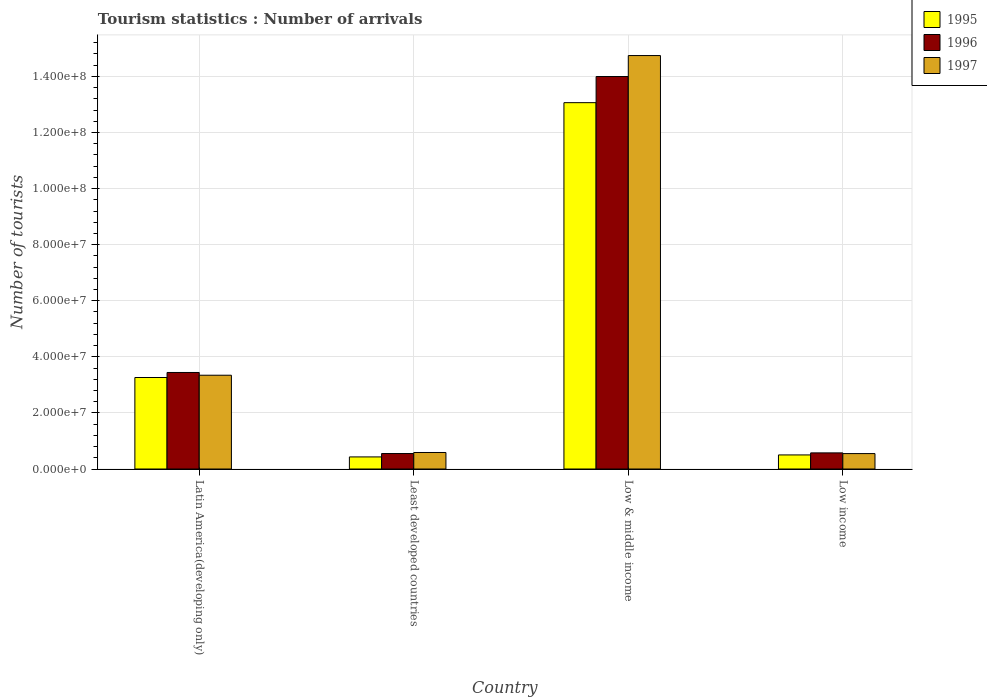Are the number of bars on each tick of the X-axis equal?
Keep it short and to the point. Yes. How many bars are there on the 3rd tick from the left?
Ensure brevity in your answer.  3. What is the label of the 2nd group of bars from the left?
Ensure brevity in your answer.  Least developed countries. What is the number of tourist arrivals in 1995 in Least developed countries?
Keep it short and to the point. 4.31e+06. Across all countries, what is the maximum number of tourist arrivals in 1995?
Provide a succinct answer. 1.31e+08. Across all countries, what is the minimum number of tourist arrivals in 1997?
Provide a succinct answer. 5.50e+06. In which country was the number of tourist arrivals in 1996 maximum?
Provide a short and direct response. Low & middle income. In which country was the number of tourist arrivals in 1996 minimum?
Your response must be concise. Least developed countries. What is the total number of tourist arrivals in 1996 in the graph?
Your answer should be compact. 1.86e+08. What is the difference between the number of tourist arrivals in 1996 in Latin America(developing only) and that in Least developed countries?
Provide a short and direct response. 2.89e+07. What is the difference between the number of tourist arrivals in 1997 in Least developed countries and the number of tourist arrivals in 1995 in Latin America(developing only)?
Offer a very short reply. -2.67e+07. What is the average number of tourist arrivals in 1996 per country?
Your answer should be compact. 4.64e+07. What is the difference between the number of tourist arrivals of/in 1996 and number of tourist arrivals of/in 1997 in Least developed countries?
Your answer should be very brief. -3.73e+05. In how many countries, is the number of tourist arrivals in 1996 greater than 8000000?
Keep it short and to the point. 2. What is the ratio of the number of tourist arrivals in 1997 in Least developed countries to that in Low & middle income?
Offer a very short reply. 0.04. Is the number of tourist arrivals in 1996 in Latin America(developing only) less than that in Least developed countries?
Offer a very short reply. No. What is the difference between the highest and the second highest number of tourist arrivals in 1996?
Your answer should be very brief. -1.06e+08. What is the difference between the highest and the lowest number of tourist arrivals in 1996?
Your response must be concise. 1.34e+08. In how many countries, is the number of tourist arrivals in 1995 greater than the average number of tourist arrivals in 1995 taken over all countries?
Give a very brief answer. 1. What does the 3rd bar from the left in Low & middle income represents?
Ensure brevity in your answer.  1997. What does the 1st bar from the right in Low income represents?
Make the answer very short. 1997. Is it the case that in every country, the sum of the number of tourist arrivals in 1996 and number of tourist arrivals in 1997 is greater than the number of tourist arrivals in 1995?
Ensure brevity in your answer.  Yes. How many countries are there in the graph?
Make the answer very short. 4. What is the difference between two consecutive major ticks on the Y-axis?
Offer a very short reply. 2.00e+07. Are the values on the major ticks of Y-axis written in scientific E-notation?
Provide a short and direct response. Yes. Does the graph contain any zero values?
Your response must be concise. No. Does the graph contain grids?
Your answer should be compact. Yes. What is the title of the graph?
Provide a succinct answer. Tourism statistics : Number of arrivals. What is the label or title of the X-axis?
Your response must be concise. Country. What is the label or title of the Y-axis?
Your answer should be very brief. Number of tourists. What is the Number of tourists in 1995 in Latin America(developing only)?
Ensure brevity in your answer.  3.26e+07. What is the Number of tourists in 1996 in Latin America(developing only)?
Keep it short and to the point. 3.44e+07. What is the Number of tourists of 1997 in Latin America(developing only)?
Your answer should be compact. 3.34e+07. What is the Number of tourists in 1995 in Least developed countries?
Make the answer very short. 4.31e+06. What is the Number of tourists in 1996 in Least developed countries?
Your answer should be compact. 5.52e+06. What is the Number of tourists in 1997 in Least developed countries?
Offer a very short reply. 5.89e+06. What is the Number of tourists in 1995 in Low & middle income?
Provide a succinct answer. 1.31e+08. What is the Number of tourists of 1996 in Low & middle income?
Offer a very short reply. 1.40e+08. What is the Number of tourists in 1997 in Low & middle income?
Offer a terse response. 1.47e+08. What is the Number of tourists in 1995 in Low income?
Your answer should be very brief. 5.03e+06. What is the Number of tourists of 1996 in Low income?
Provide a succinct answer. 5.75e+06. What is the Number of tourists of 1997 in Low income?
Make the answer very short. 5.50e+06. Across all countries, what is the maximum Number of tourists in 1995?
Keep it short and to the point. 1.31e+08. Across all countries, what is the maximum Number of tourists in 1996?
Make the answer very short. 1.40e+08. Across all countries, what is the maximum Number of tourists in 1997?
Ensure brevity in your answer.  1.47e+08. Across all countries, what is the minimum Number of tourists of 1995?
Keep it short and to the point. 4.31e+06. Across all countries, what is the minimum Number of tourists of 1996?
Ensure brevity in your answer.  5.52e+06. Across all countries, what is the minimum Number of tourists in 1997?
Provide a succinct answer. 5.50e+06. What is the total Number of tourists in 1995 in the graph?
Give a very brief answer. 1.73e+08. What is the total Number of tourists of 1996 in the graph?
Keep it short and to the point. 1.86e+08. What is the total Number of tourists in 1997 in the graph?
Your answer should be very brief. 1.92e+08. What is the difference between the Number of tourists of 1995 in Latin America(developing only) and that in Least developed countries?
Offer a terse response. 2.83e+07. What is the difference between the Number of tourists in 1996 in Latin America(developing only) and that in Least developed countries?
Keep it short and to the point. 2.89e+07. What is the difference between the Number of tourists of 1997 in Latin America(developing only) and that in Least developed countries?
Provide a succinct answer. 2.76e+07. What is the difference between the Number of tourists of 1995 in Latin America(developing only) and that in Low & middle income?
Your answer should be very brief. -9.80e+07. What is the difference between the Number of tourists in 1996 in Latin America(developing only) and that in Low & middle income?
Your answer should be compact. -1.06e+08. What is the difference between the Number of tourists of 1997 in Latin America(developing only) and that in Low & middle income?
Offer a terse response. -1.14e+08. What is the difference between the Number of tourists of 1995 in Latin America(developing only) and that in Low income?
Provide a short and direct response. 2.76e+07. What is the difference between the Number of tourists of 1996 in Latin America(developing only) and that in Low income?
Your answer should be compact. 2.87e+07. What is the difference between the Number of tourists in 1997 in Latin America(developing only) and that in Low income?
Make the answer very short. 2.79e+07. What is the difference between the Number of tourists in 1995 in Least developed countries and that in Low & middle income?
Your response must be concise. -1.26e+08. What is the difference between the Number of tourists in 1996 in Least developed countries and that in Low & middle income?
Provide a short and direct response. -1.34e+08. What is the difference between the Number of tourists in 1997 in Least developed countries and that in Low & middle income?
Your response must be concise. -1.42e+08. What is the difference between the Number of tourists in 1995 in Least developed countries and that in Low income?
Keep it short and to the point. -7.12e+05. What is the difference between the Number of tourists in 1996 in Least developed countries and that in Low income?
Keep it short and to the point. -2.32e+05. What is the difference between the Number of tourists in 1997 in Least developed countries and that in Low income?
Provide a succinct answer. 3.90e+05. What is the difference between the Number of tourists of 1995 in Low & middle income and that in Low income?
Make the answer very short. 1.26e+08. What is the difference between the Number of tourists in 1996 in Low & middle income and that in Low income?
Your answer should be very brief. 1.34e+08. What is the difference between the Number of tourists in 1997 in Low & middle income and that in Low income?
Give a very brief answer. 1.42e+08. What is the difference between the Number of tourists of 1995 in Latin America(developing only) and the Number of tourists of 1996 in Least developed countries?
Your answer should be compact. 2.71e+07. What is the difference between the Number of tourists of 1995 in Latin America(developing only) and the Number of tourists of 1997 in Least developed countries?
Ensure brevity in your answer.  2.67e+07. What is the difference between the Number of tourists of 1996 in Latin America(developing only) and the Number of tourists of 1997 in Least developed countries?
Your answer should be very brief. 2.85e+07. What is the difference between the Number of tourists in 1995 in Latin America(developing only) and the Number of tourists in 1996 in Low & middle income?
Keep it short and to the point. -1.07e+08. What is the difference between the Number of tourists of 1995 in Latin America(developing only) and the Number of tourists of 1997 in Low & middle income?
Offer a very short reply. -1.15e+08. What is the difference between the Number of tourists in 1996 in Latin America(developing only) and the Number of tourists in 1997 in Low & middle income?
Offer a terse response. -1.13e+08. What is the difference between the Number of tourists in 1995 in Latin America(developing only) and the Number of tourists in 1996 in Low income?
Your answer should be very brief. 2.69e+07. What is the difference between the Number of tourists in 1995 in Latin America(developing only) and the Number of tourists in 1997 in Low income?
Give a very brief answer. 2.71e+07. What is the difference between the Number of tourists in 1996 in Latin America(developing only) and the Number of tourists in 1997 in Low income?
Your response must be concise. 2.89e+07. What is the difference between the Number of tourists of 1995 in Least developed countries and the Number of tourists of 1996 in Low & middle income?
Ensure brevity in your answer.  -1.36e+08. What is the difference between the Number of tourists of 1995 in Least developed countries and the Number of tourists of 1997 in Low & middle income?
Give a very brief answer. -1.43e+08. What is the difference between the Number of tourists of 1996 in Least developed countries and the Number of tourists of 1997 in Low & middle income?
Your answer should be compact. -1.42e+08. What is the difference between the Number of tourists of 1995 in Least developed countries and the Number of tourists of 1996 in Low income?
Your response must be concise. -1.44e+06. What is the difference between the Number of tourists in 1995 in Least developed countries and the Number of tourists in 1997 in Low income?
Make the answer very short. -1.19e+06. What is the difference between the Number of tourists in 1996 in Least developed countries and the Number of tourists in 1997 in Low income?
Offer a very short reply. 1.72e+04. What is the difference between the Number of tourists of 1995 in Low & middle income and the Number of tourists of 1996 in Low income?
Offer a terse response. 1.25e+08. What is the difference between the Number of tourists in 1995 in Low & middle income and the Number of tourists in 1997 in Low income?
Ensure brevity in your answer.  1.25e+08. What is the difference between the Number of tourists of 1996 in Low & middle income and the Number of tourists of 1997 in Low income?
Offer a terse response. 1.34e+08. What is the average Number of tourists in 1995 per country?
Your answer should be very brief. 4.32e+07. What is the average Number of tourists of 1996 per country?
Provide a short and direct response. 4.64e+07. What is the average Number of tourists of 1997 per country?
Ensure brevity in your answer.  4.81e+07. What is the difference between the Number of tourists in 1995 and Number of tourists in 1996 in Latin America(developing only)?
Ensure brevity in your answer.  -1.79e+06. What is the difference between the Number of tourists of 1995 and Number of tourists of 1997 in Latin America(developing only)?
Your answer should be very brief. -8.13e+05. What is the difference between the Number of tourists of 1996 and Number of tourists of 1997 in Latin America(developing only)?
Make the answer very short. 9.79e+05. What is the difference between the Number of tourists in 1995 and Number of tourists in 1996 in Least developed countries?
Offer a very short reply. -1.21e+06. What is the difference between the Number of tourists in 1995 and Number of tourists in 1997 in Least developed countries?
Provide a succinct answer. -1.58e+06. What is the difference between the Number of tourists in 1996 and Number of tourists in 1997 in Least developed countries?
Your answer should be very brief. -3.73e+05. What is the difference between the Number of tourists in 1995 and Number of tourists in 1996 in Low & middle income?
Ensure brevity in your answer.  -9.32e+06. What is the difference between the Number of tourists of 1995 and Number of tourists of 1997 in Low & middle income?
Keep it short and to the point. -1.68e+07. What is the difference between the Number of tourists of 1996 and Number of tourists of 1997 in Low & middle income?
Offer a very short reply. -7.48e+06. What is the difference between the Number of tourists of 1995 and Number of tourists of 1996 in Low income?
Provide a succinct answer. -7.27e+05. What is the difference between the Number of tourists in 1995 and Number of tourists in 1997 in Low income?
Give a very brief answer. -4.78e+05. What is the difference between the Number of tourists of 1996 and Number of tourists of 1997 in Low income?
Your answer should be compact. 2.49e+05. What is the ratio of the Number of tourists in 1995 in Latin America(developing only) to that in Least developed countries?
Your answer should be very brief. 7.56. What is the ratio of the Number of tourists in 1996 in Latin America(developing only) to that in Least developed countries?
Give a very brief answer. 6.24. What is the ratio of the Number of tourists in 1997 in Latin America(developing only) to that in Least developed countries?
Offer a very short reply. 5.67. What is the ratio of the Number of tourists in 1995 in Latin America(developing only) to that in Low & middle income?
Give a very brief answer. 0.25. What is the ratio of the Number of tourists in 1996 in Latin America(developing only) to that in Low & middle income?
Provide a short and direct response. 0.25. What is the ratio of the Number of tourists in 1997 in Latin America(developing only) to that in Low & middle income?
Your answer should be compact. 0.23. What is the ratio of the Number of tourists of 1995 in Latin America(developing only) to that in Low income?
Your answer should be compact. 6.49. What is the ratio of the Number of tourists in 1996 in Latin America(developing only) to that in Low income?
Your answer should be compact. 5.98. What is the ratio of the Number of tourists of 1997 in Latin America(developing only) to that in Low income?
Keep it short and to the point. 6.08. What is the ratio of the Number of tourists of 1995 in Least developed countries to that in Low & middle income?
Ensure brevity in your answer.  0.03. What is the ratio of the Number of tourists of 1996 in Least developed countries to that in Low & middle income?
Provide a short and direct response. 0.04. What is the ratio of the Number of tourists in 1995 in Least developed countries to that in Low income?
Provide a succinct answer. 0.86. What is the ratio of the Number of tourists of 1996 in Least developed countries to that in Low income?
Offer a very short reply. 0.96. What is the ratio of the Number of tourists of 1997 in Least developed countries to that in Low income?
Offer a very short reply. 1.07. What is the ratio of the Number of tourists of 1995 in Low & middle income to that in Low income?
Your response must be concise. 26. What is the ratio of the Number of tourists of 1996 in Low & middle income to that in Low income?
Give a very brief answer. 24.33. What is the ratio of the Number of tourists of 1997 in Low & middle income to that in Low income?
Your answer should be compact. 26.79. What is the difference between the highest and the second highest Number of tourists in 1995?
Provide a short and direct response. 9.80e+07. What is the difference between the highest and the second highest Number of tourists in 1996?
Give a very brief answer. 1.06e+08. What is the difference between the highest and the second highest Number of tourists of 1997?
Offer a terse response. 1.14e+08. What is the difference between the highest and the lowest Number of tourists of 1995?
Your answer should be very brief. 1.26e+08. What is the difference between the highest and the lowest Number of tourists of 1996?
Give a very brief answer. 1.34e+08. What is the difference between the highest and the lowest Number of tourists in 1997?
Keep it short and to the point. 1.42e+08. 